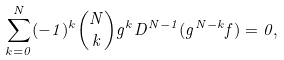<formula> <loc_0><loc_0><loc_500><loc_500>\sum _ { k = 0 } ^ { N } ( - 1 ) ^ { k } \binom { N } { k } g ^ { k } D ^ { N - 1 } ( g ^ { N - k } f ) = 0 ,</formula> 